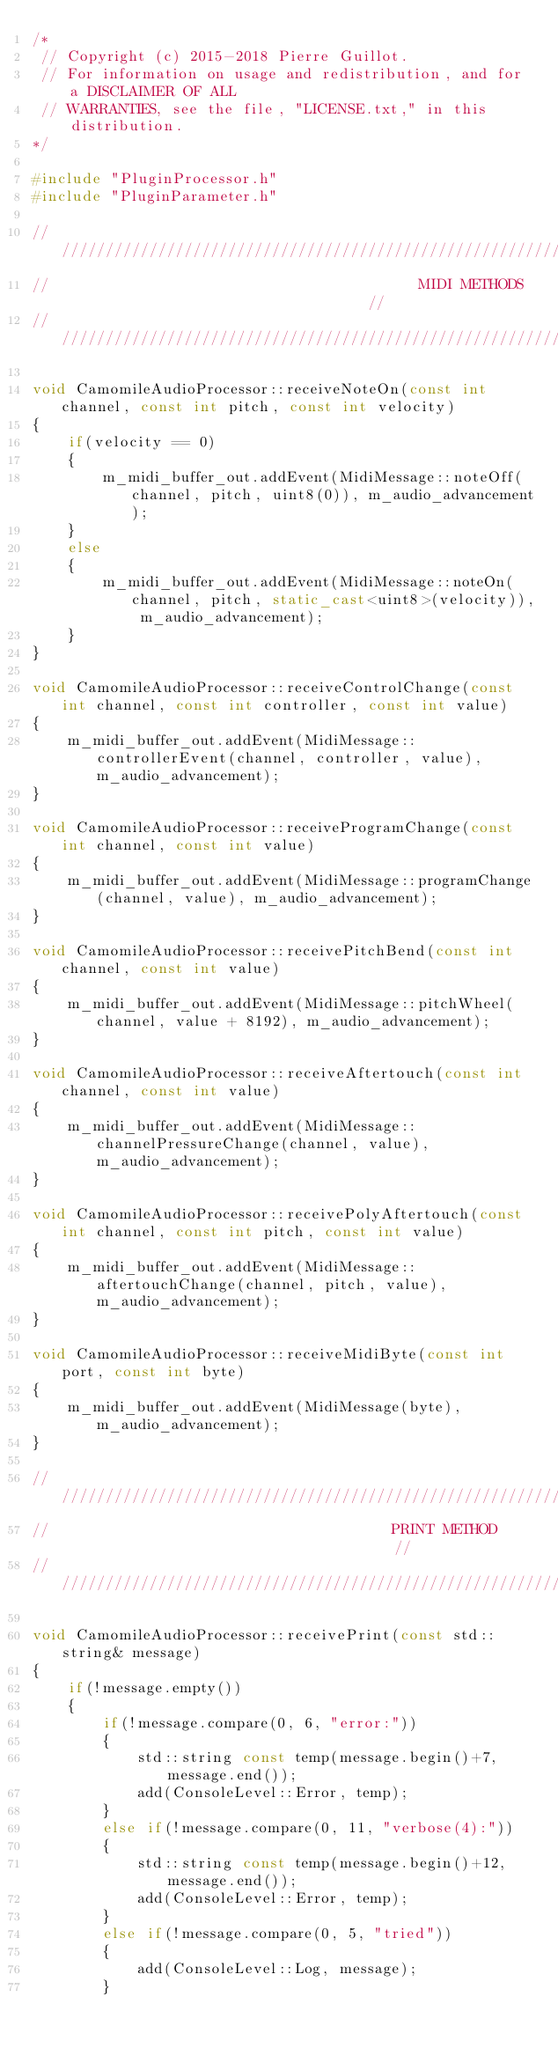Convert code to text. <code><loc_0><loc_0><loc_500><loc_500><_C++_>/*
 // Copyright (c) 2015-2018 Pierre Guillot.
 // For information on usage and redistribution, and for a DISCLAIMER OF ALL
 // WARRANTIES, see the file, "LICENSE.txt," in this distribution.
*/

#include "PluginProcessor.h"
#include "PluginParameter.h"

//////////////////////////////////////////////////////////////////////////////////////////////
//                                          MIDI METHODS                                    //
//////////////////////////////////////////////////////////////////////////////////////////////

void CamomileAudioProcessor::receiveNoteOn(const int channel, const int pitch, const int velocity)
{
    if(velocity == 0)
    {
        m_midi_buffer_out.addEvent(MidiMessage::noteOff(channel, pitch, uint8(0)), m_audio_advancement);
    }
    else
    {
        m_midi_buffer_out.addEvent(MidiMessage::noteOn(channel, pitch, static_cast<uint8>(velocity)), m_audio_advancement);
    }
}

void CamomileAudioProcessor::receiveControlChange(const int channel, const int controller, const int value)
{
    m_midi_buffer_out.addEvent(MidiMessage::controllerEvent(channel, controller, value), m_audio_advancement);
}

void CamomileAudioProcessor::receiveProgramChange(const int channel, const int value)
{
    m_midi_buffer_out.addEvent(MidiMessage::programChange(channel, value), m_audio_advancement);
}

void CamomileAudioProcessor::receivePitchBend(const int channel, const int value)
{
    m_midi_buffer_out.addEvent(MidiMessage::pitchWheel(channel, value + 8192), m_audio_advancement);
}

void CamomileAudioProcessor::receiveAftertouch(const int channel, const int value)
{
    m_midi_buffer_out.addEvent(MidiMessage::channelPressureChange(channel, value), m_audio_advancement);
}

void CamomileAudioProcessor::receivePolyAftertouch(const int channel, const int pitch, const int value)
{
    m_midi_buffer_out.addEvent(MidiMessage::aftertouchChange(channel, pitch, value), m_audio_advancement);
}

void CamomileAudioProcessor::receiveMidiByte(const int port, const int byte)
{
    m_midi_buffer_out.addEvent(MidiMessage(byte), m_audio_advancement);
}

//////////////////////////////////////////////////////////////////////////////////////////////
//                                       PRINT METHOD                                       //
//////////////////////////////////////////////////////////////////////////////////////////////

void CamomileAudioProcessor::receivePrint(const std::string& message)
{
    if(!message.empty())
    {
        if(!message.compare(0, 6, "error:"))
        {
            std::string const temp(message.begin()+7, message.end());
            add(ConsoleLevel::Error, temp);
        }
        else if(!message.compare(0, 11, "verbose(4):"))
        {
            std::string const temp(message.begin()+12, message.end());
            add(ConsoleLevel::Error, temp);
        }
        else if(!message.compare(0, 5, "tried"))
        {
            add(ConsoleLevel::Log, message);
        }</code> 